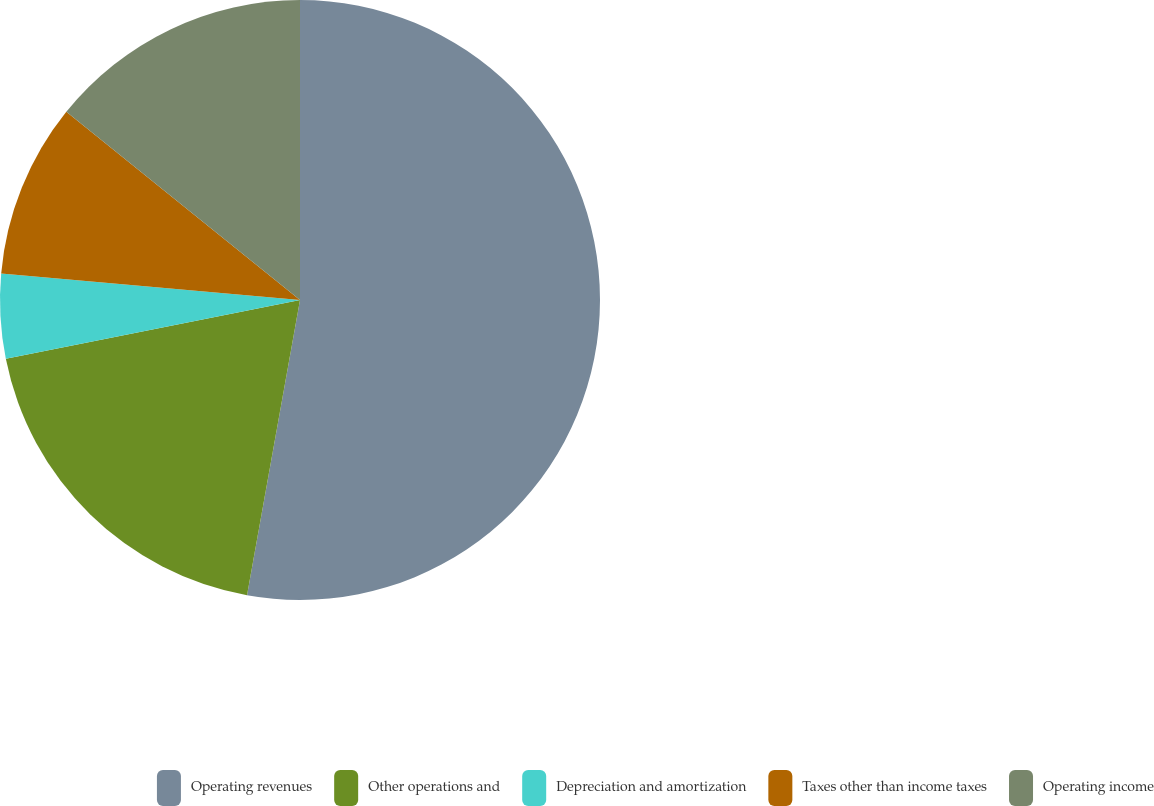Convert chart. <chart><loc_0><loc_0><loc_500><loc_500><pie_chart><fcel>Operating revenues<fcel>Other operations and<fcel>Depreciation and amortization<fcel>Taxes other than income taxes<fcel>Operating income<nl><fcel>52.82%<fcel>19.03%<fcel>4.55%<fcel>9.38%<fcel>14.21%<nl></chart> 